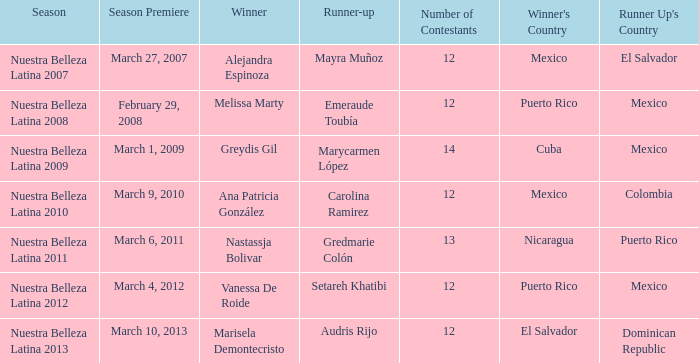Could you help me parse every detail presented in this table? {'header': ['Season', 'Season Premiere', 'Winner', 'Runner-up', 'Number of Contestants', "Winner's Country", "Runner Up's Country"], 'rows': [['Nuestra Belleza Latina 2007', 'March 27, 2007', 'Alejandra Espinoza', 'Mayra Muñoz', '12', 'Mexico', 'El Salvador'], ['Nuestra Belleza Latina 2008', 'February 29, 2008', 'Melissa Marty', 'Emeraude Toubía', '12', 'Puerto Rico', 'Mexico'], ['Nuestra Belleza Latina 2009', 'March 1, 2009', 'Greydis Gil', 'Marycarmen López', '14', 'Cuba', 'Mexico'], ['Nuestra Belleza Latina 2010', 'March 9, 2010', 'Ana Patricia González', 'Carolina Ramirez', '12', 'Mexico', 'Colombia'], ['Nuestra Belleza Latina 2011', 'March 6, 2011', 'Nastassja Bolivar', 'Gredmarie Colón', '13', 'Nicaragua', 'Puerto Rico'], ['Nuestra Belleza Latina 2012', 'March 4, 2012', 'Vanessa De Roide', 'Setareh Khatibi', '12', 'Puerto Rico', 'Mexico'], ['Nuestra Belleza Latina 2013', 'March 10, 2013', 'Marisela Demontecristo', 'Audris Rijo', '12', 'El Salvador', 'Dominican Republic']]} How many participants were present on march 1, 2009 during the season premiere? 14.0. 